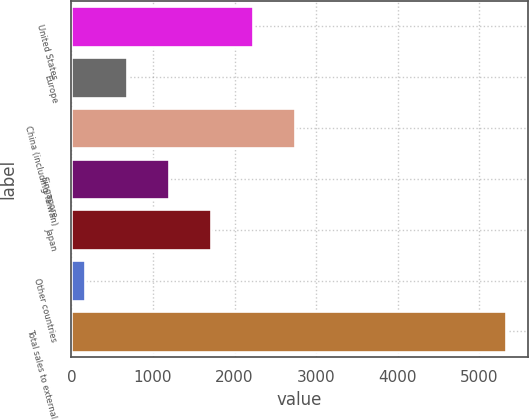Convert chart to OTSL. <chart><loc_0><loc_0><loc_500><loc_500><bar_chart><fcel>United States<fcel>Europe<fcel>China (including Taiwan)<fcel>Singapore<fcel>Japan<fcel>Other countries<fcel>Total sales to external<nl><fcel>2228.8<fcel>678.7<fcel>2745.5<fcel>1195.4<fcel>1712.1<fcel>162<fcel>5329<nl></chart> 